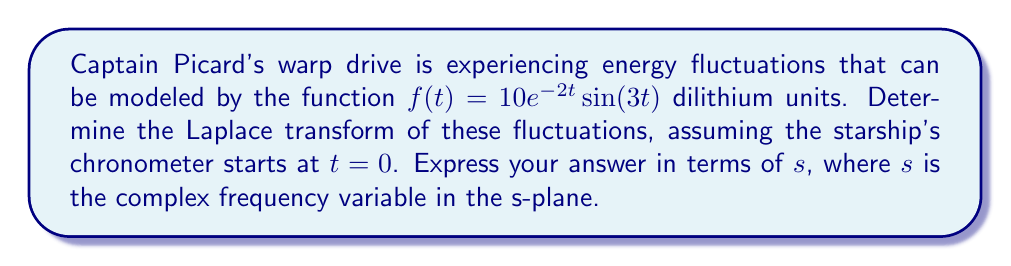Could you help me with this problem? To solve this problem, we'll use the Laplace transform of a damped sinusoidal function. The general form of the Laplace transform for $f(t) = e^{at}\sin(bt)$ is:

$$\mathcal{L}\{e^{at}\sin(bt)\} = \frac{b}{(s-a)^2 + b^2}$$

In our case, we have:
$f(t) = 10e^{-2t}\sin(3t)$

Comparing to the general form:
$a = -2$
$b = 3$
We also have a constant factor of 10.

Therefore, we can write our Laplace transform as:

$$\mathcal{L}\{10e^{-2t}\sin(3t)\} = 10 \cdot \frac{3}{(s-(-2))^2 + 3^2}$$

Simplifying:

$$\mathcal{L}\{10e^{-2t}\sin(3t)\} = 10 \cdot \frac{3}{(s+2)^2 + 9}$$

$$= \frac{30}{s^2 + 4s + 13}$$

This final form represents the Laplace transform of our warp drive's energy fluctuations in the s-plane, ready for further analysis by the Enterprise's engineering team.
Answer: $$\mathcal{L}\{10e^{-2t}\sin(3t)\} = \frac{30}{s^2 + 4s + 13}$$ 